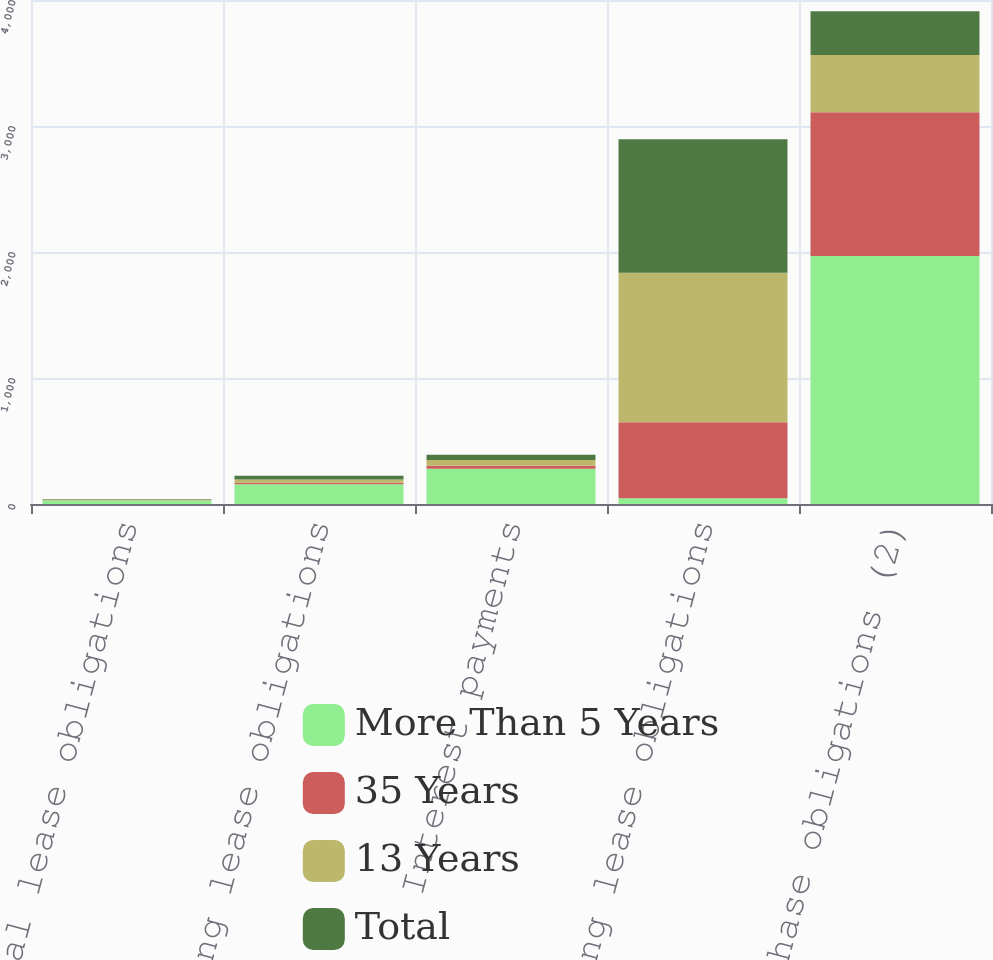<chart> <loc_0><loc_0><loc_500><loc_500><stacked_bar_chart><ecel><fcel>Capital lease obligations<fcel>Financing lease obligations<fcel>Interest payments<fcel>Operating lease obligations<fcel>Purchase obligations (2)<nl><fcel>More Than 5 Years<fcel>27<fcel>157<fcel>280<fcel>46<fcel>1968<nl><fcel>35 Years<fcel>3<fcel>12<fcel>24<fcel>602<fcel>1141<nl><fcel>13 Years<fcel>6<fcel>26<fcel>46<fcel>1187<fcel>454<nl><fcel>Total<fcel>4<fcel>29<fcel>41<fcel>1059<fcel>347<nl></chart> 